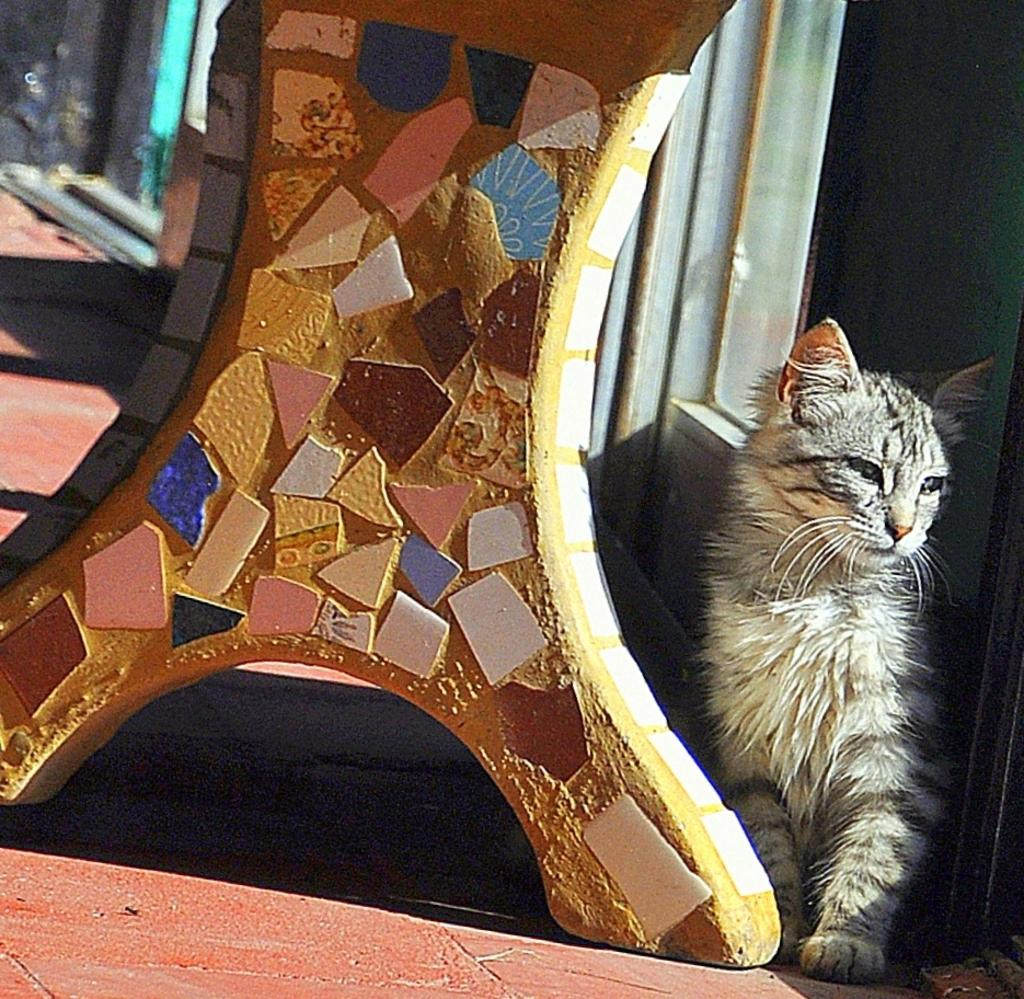Where was the image taken? The image is taken outdoors. What is at the bottom of the image? There is a floor at the bottom of the image. What can be seen in the middle of the image? There is a bench in the middle of the image. What type of animal is on the right side of the image? There is a cat on the right side of the image. What type of guide is helping the cat in the image? There is no guide present in the image, and the cat does not require assistance. 